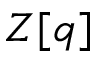Convert formula to latex. <formula><loc_0><loc_0><loc_500><loc_500>Z [ q ]</formula> 